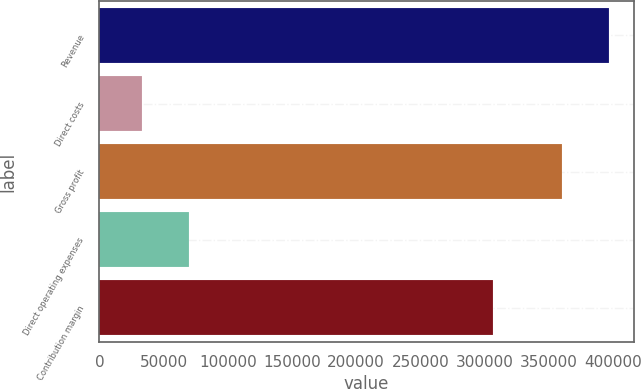<chart> <loc_0><loc_0><loc_500><loc_500><bar_chart><fcel>Revenue<fcel>Direct costs<fcel>Gross profit<fcel>Direct operating expenses<fcel>Contribution margin<nl><fcel>396625<fcel>33505<fcel>360568<fcel>69561.8<fcel>306655<nl></chart> 